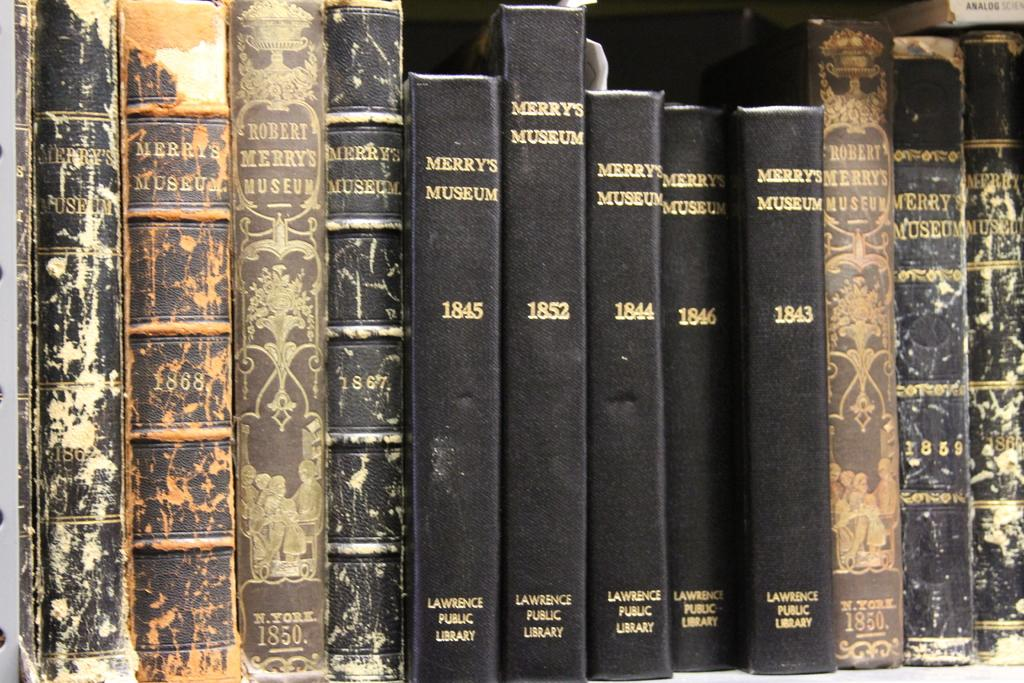What type of furniture is present in the image? There is a bookshelf in the image. What can be found on the bookshelf? The bookshelf contains books with black and brown book spines. What can be seen on the book spines? There is text printed on the book spines. How does the honey smash the attention of the books in the image? There is no honey or attention present in the image; it only features a bookshelf with books. 